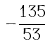<formula> <loc_0><loc_0><loc_500><loc_500>- \frac { 1 3 5 } { 5 3 }</formula> 